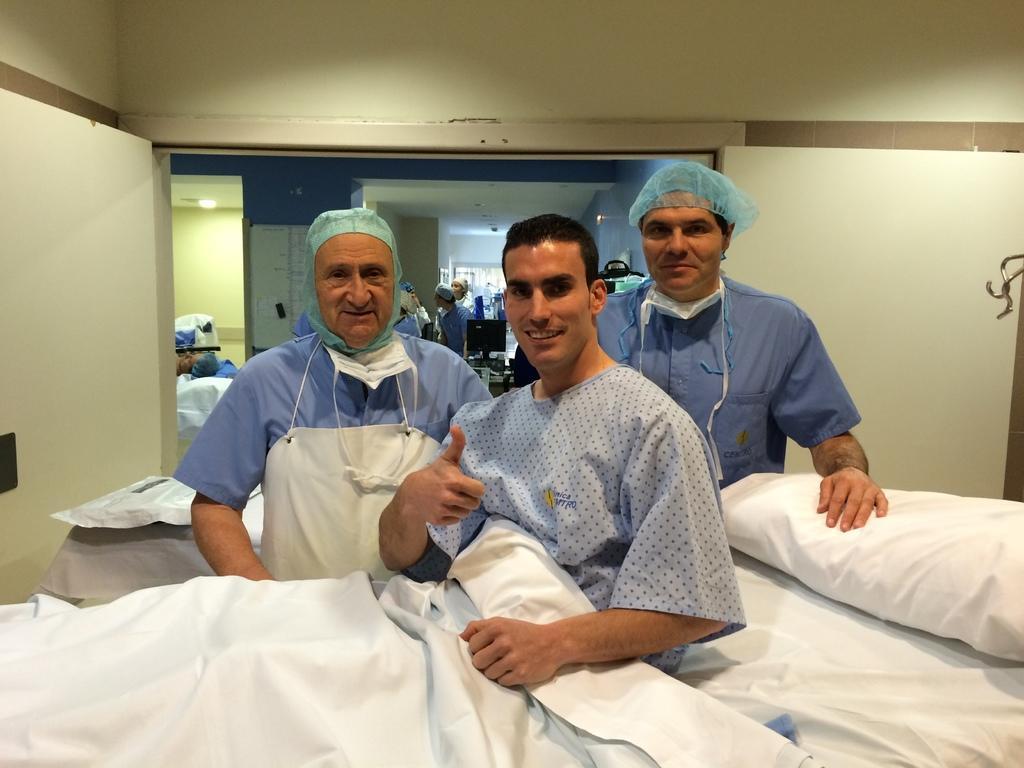How would you summarize this image in a sentence or two? In this image there are group of persons standing, there is a man sitting on a bed, there is a pillow, there is a blanket, there is a man lying on the bed, there is a monitor, there is an object towards the right of the image, there is a wall towards the top of the image, there is a light, there is a roof. 